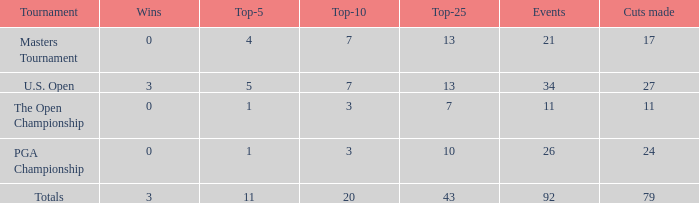Name the sum of top-25 for pga championship and top-5 less than 1 None. 